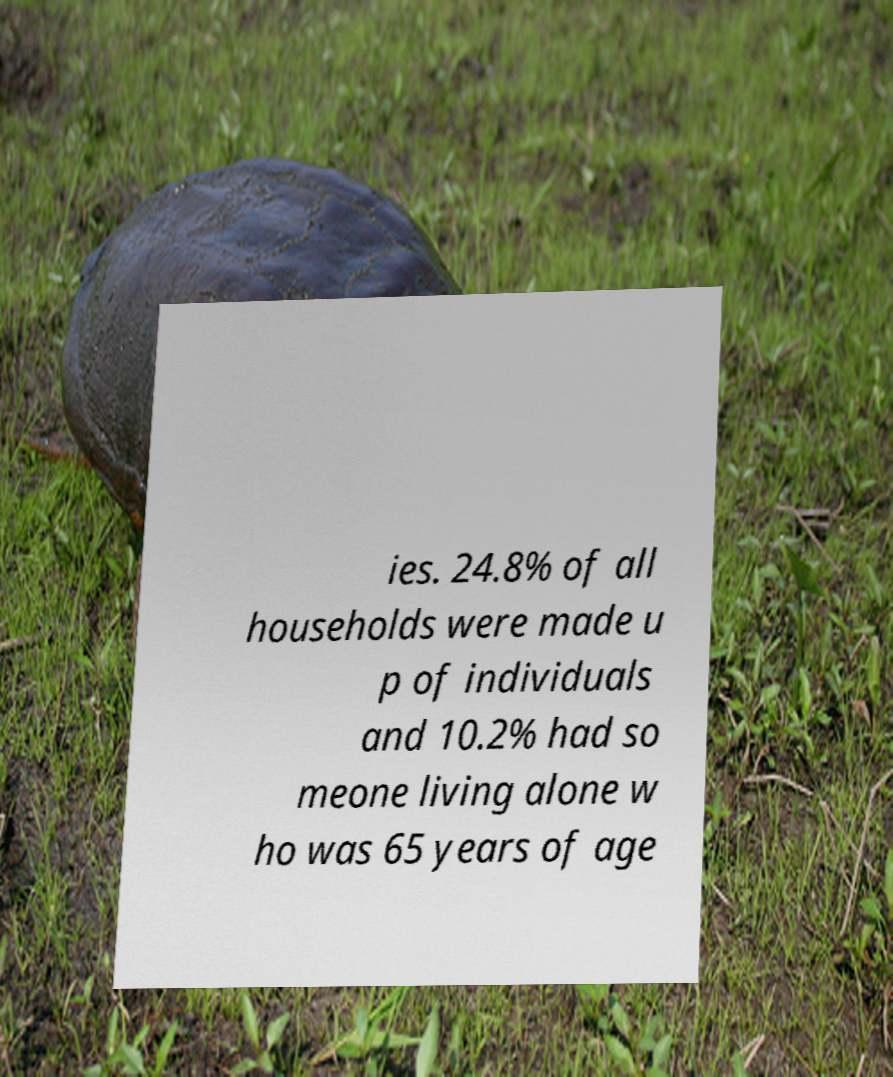Please identify and transcribe the text found in this image. ies. 24.8% of all households were made u p of individuals and 10.2% had so meone living alone w ho was 65 years of age 